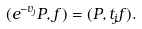Convert formula to latex. <formula><loc_0><loc_0><loc_500><loc_500>( e ^ { - v _ { j } } P , f ) = ( P , t _ { j } f ) .</formula> 